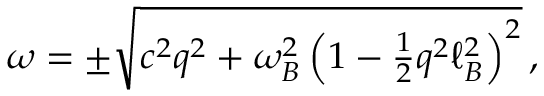Convert formula to latex. <formula><loc_0><loc_0><loc_500><loc_500>\begin{array} { r } { \omega = \pm \sqrt { c ^ { 2 } q ^ { 2 } + \omega _ { B } ^ { 2 } \left ( 1 - \frac { 1 } { 2 } q ^ { 2 } \ell _ { B } ^ { 2 } \right ) ^ { 2 } } \, , } \end{array}</formula> 